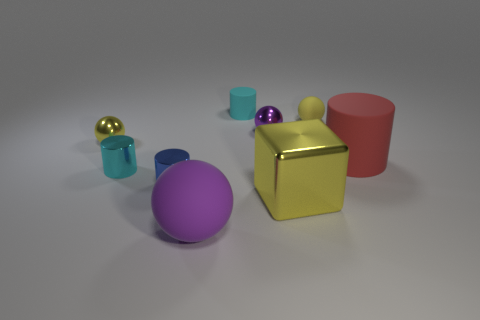Subtract all tiny purple metal balls. How many balls are left? 3 Subtract 4 cylinders. How many cylinders are left? 0 Add 1 tiny brown rubber cylinders. How many objects exist? 10 Subtract all purple balls. How many balls are left? 2 Subtract all blue cylinders. Subtract all yellow balls. How many cylinders are left? 3 Subtract all gray blocks. How many cyan cylinders are left? 2 Add 3 yellow shiny blocks. How many yellow shiny blocks are left? 4 Add 4 brown balls. How many brown balls exist? 4 Subtract 0 brown balls. How many objects are left? 9 Subtract all balls. How many objects are left? 5 